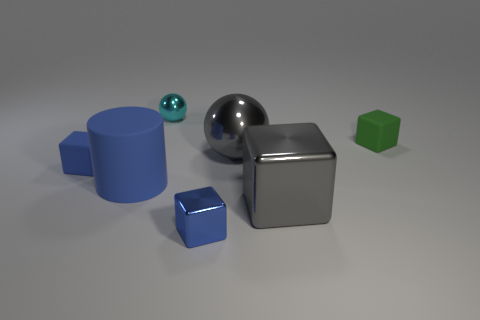There is a large matte thing; is its color the same as the small matte thing that is left of the small blue shiny thing?
Your answer should be compact. Yes. Is there any other thing of the same color as the small sphere?
Give a very brief answer. No. Does the tiny cyan ball have the same material as the block behind the blue rubber block?
Provide a short and direct response. No. There is a large gray object behind the rubber cube that is in front of the small green block; what is its shape?
Provide a succinct answer. Sphere. The matte object that is in front of the green rubber object and behind the rubber cylinder has what shape?
Provide a short and direct response. Cube. How many things are blue shiny things or metal cubes left of the gray ball?
Your response must be concise. 1. What material is the tiny green thing that is the same shape as the small blue matte thing?
Keep it short and to the point. Rubber. There is a tiny cube that is left of the green rubber thing and right of the cyan metal thing; what material is it?
Give a very brief answer. Metal. What number of blue shiny things have the same shape as the small cyan object?
Keep it short and to the point. 0. There is a block behind the metal ball in front of the green cube; what color is it?
Keep it short and to the point. Green. 